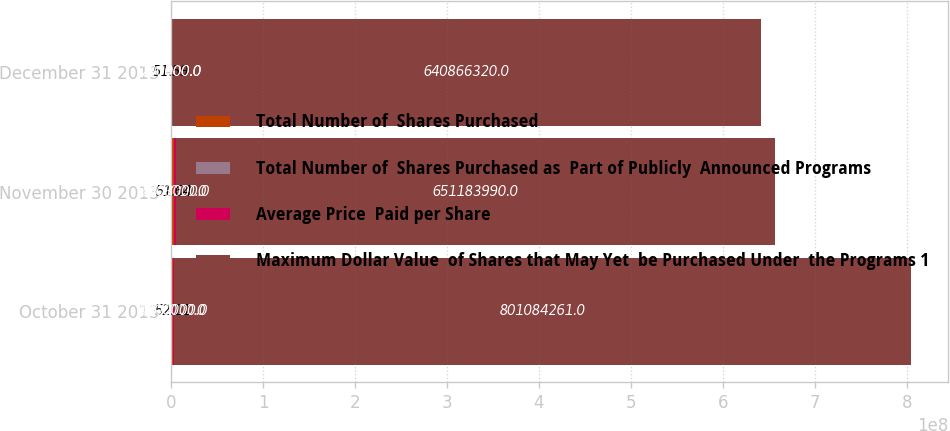Convert chart. <chart><loc_0><loc_0><loc_500><loc_500><stacked_bar_chart><ecel><fcel>October 31 2013<fcel>November 30 2013<fcel>December 31 2013<nl><fcel>Total Number of  Shares Purchased<fcel>1.8e+06<fcel>2.903e+06<fcel>200000<nl><fcel>Total Number of  Shares Purchased as  Part of Publicly  Announced Programs<fcel>52.11<fcel>51.64<fcel>51.59<nl><fcel>Average Price  Paid per Share<fcel>1.8e+06<fcel>2.903e+06<fcel>200000<nl><fcel>Maximum Dollar Value  of Shares that May Yet  be Purchased Under  the Programs 1<fcel>8.01084e+08<fcel>6.51184e+08<fcel>6.40866e+08<nl></chart> 